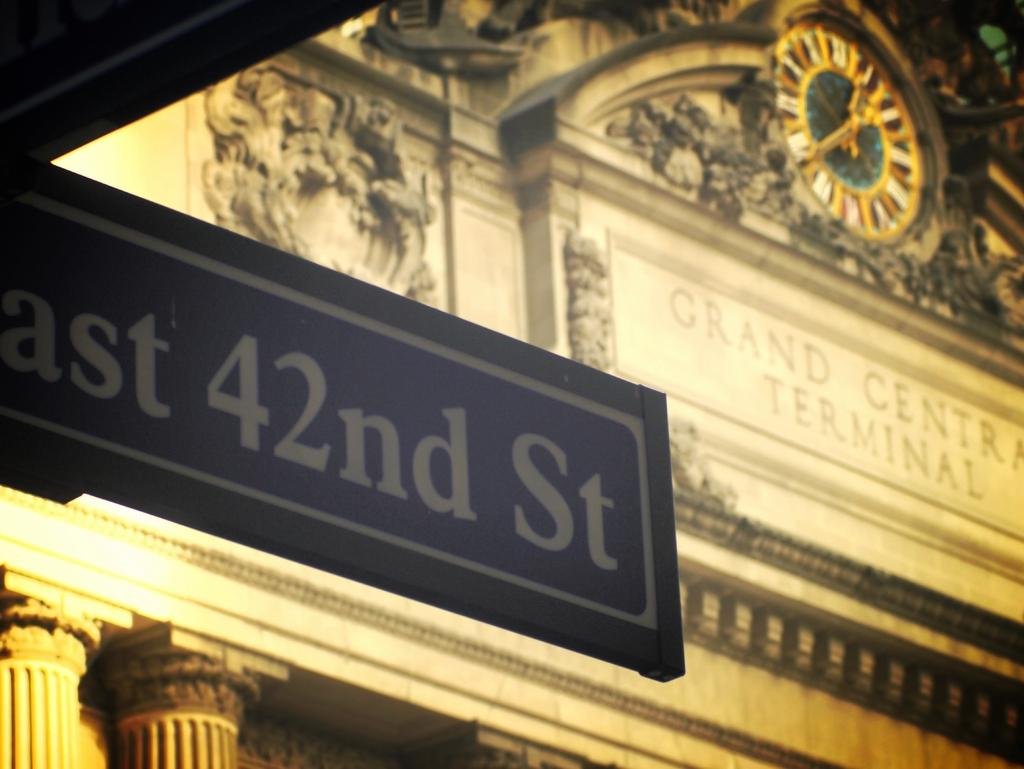<image>
Describe the image concisely. A street sign for East 42nd Street is seen outside Grand Central Terminal. 